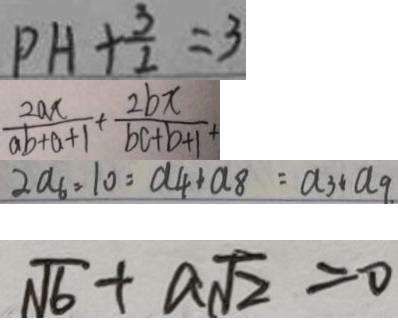<formula> <loc_0><loc_0><loc_500><loc_500>P H + \frac { 3 } { 2 } = 3 
 \frac { 2 a x } { a b + a + 1 } + \frac { 2 b x } { b c + b + 1 } + 
 2 a _ { 6 } = 1 0 = a _ { 4 } + a _ { 8 } = a _ { 3 } + a _ { 9 } . 
 \sqrt { 6 } + a \sqrt { 2 } = 0</formula> 